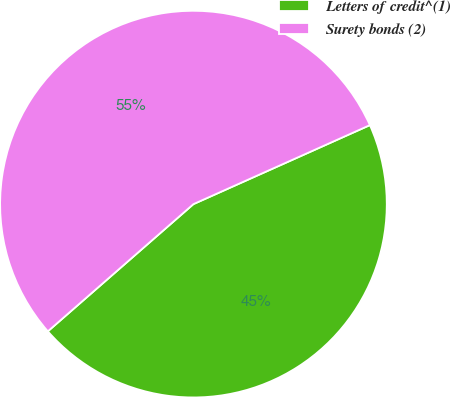Convert chart to OTSL. <chart><loc_0><loc_0><loc_500><loc_500><pie_chart><fcel>Letters of credit^(1)<fcel>Surety bonds (2)<nl><fcel>45.27%<fcel>54.73%<nl></chart> 